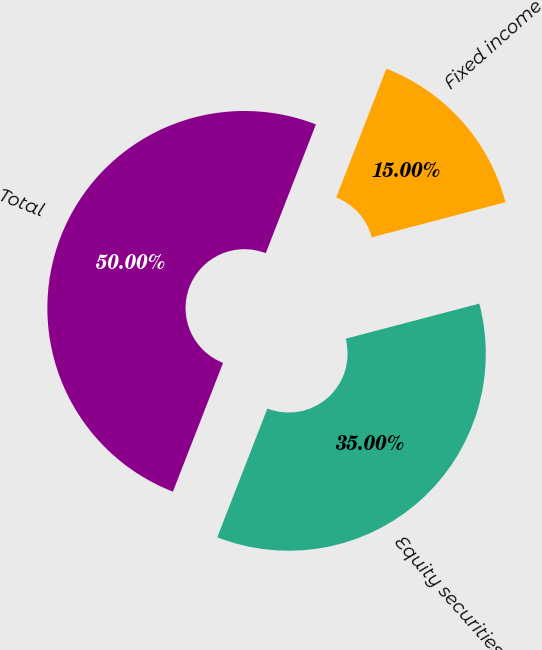<chart> <loc_0><loc_0><loc_500><loc_500><pie_chart><fcel>Equity securities<fcel>Fixed income<fcel>Total<nl><fcel>35.0%<fcel>15.0%<fcel>50.0%<nl></chart> 